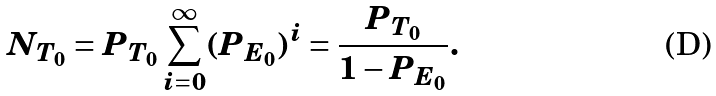<formula> <loc_0><loc_0><loc_500><loc_500>N _ { T _ { 0 } } = P _ { T _ { 0 } } \sum ^ { \infty } _ { i = 0 } ( P _ { E _ { 0 } } ) ^ { i } = \frac { P _ { T _ { 0 } } } { 1 - P _ { E _ { 0 } } } .</formula> 